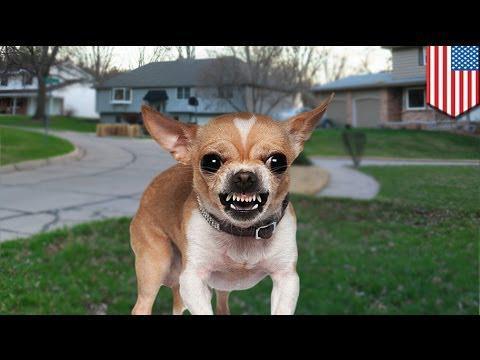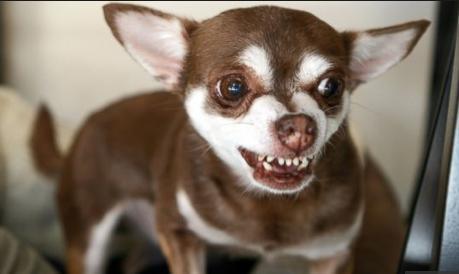The first image is the image on the left, the second image is the image on the right. Examine the images to the left and right. Is the description "Each image includes a white chihuahua, and the one in the right image faces forward with erect ears." accurate? Answer yes or no. No. The first image is the image on the left, the second image is the image on the right. Analyze the images presented: Is the assertion "At least one of the dogs is wearing a collar." valid? Answer yes or no. Yes. 